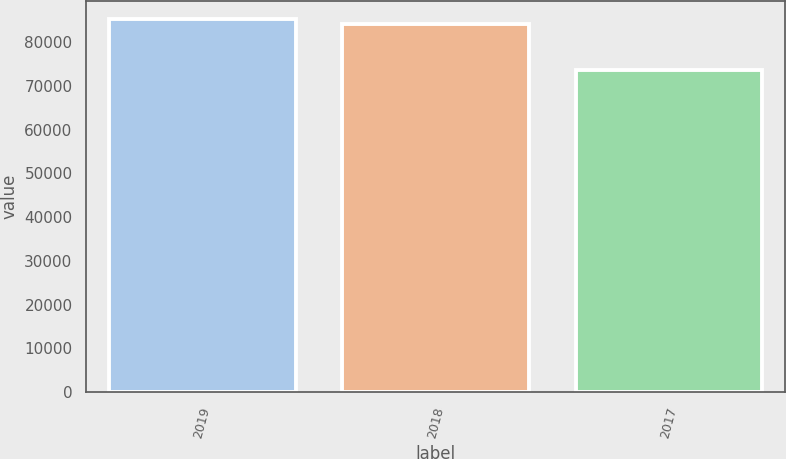Convert chart. <chart><loc_0><loc_0><loc_500><loc_500><bar_chart><fcel>2019<fcel>2018<fcel>2017<nl><fcel>85196.3<fcel>84051<fcel>73701<nl></chart> 